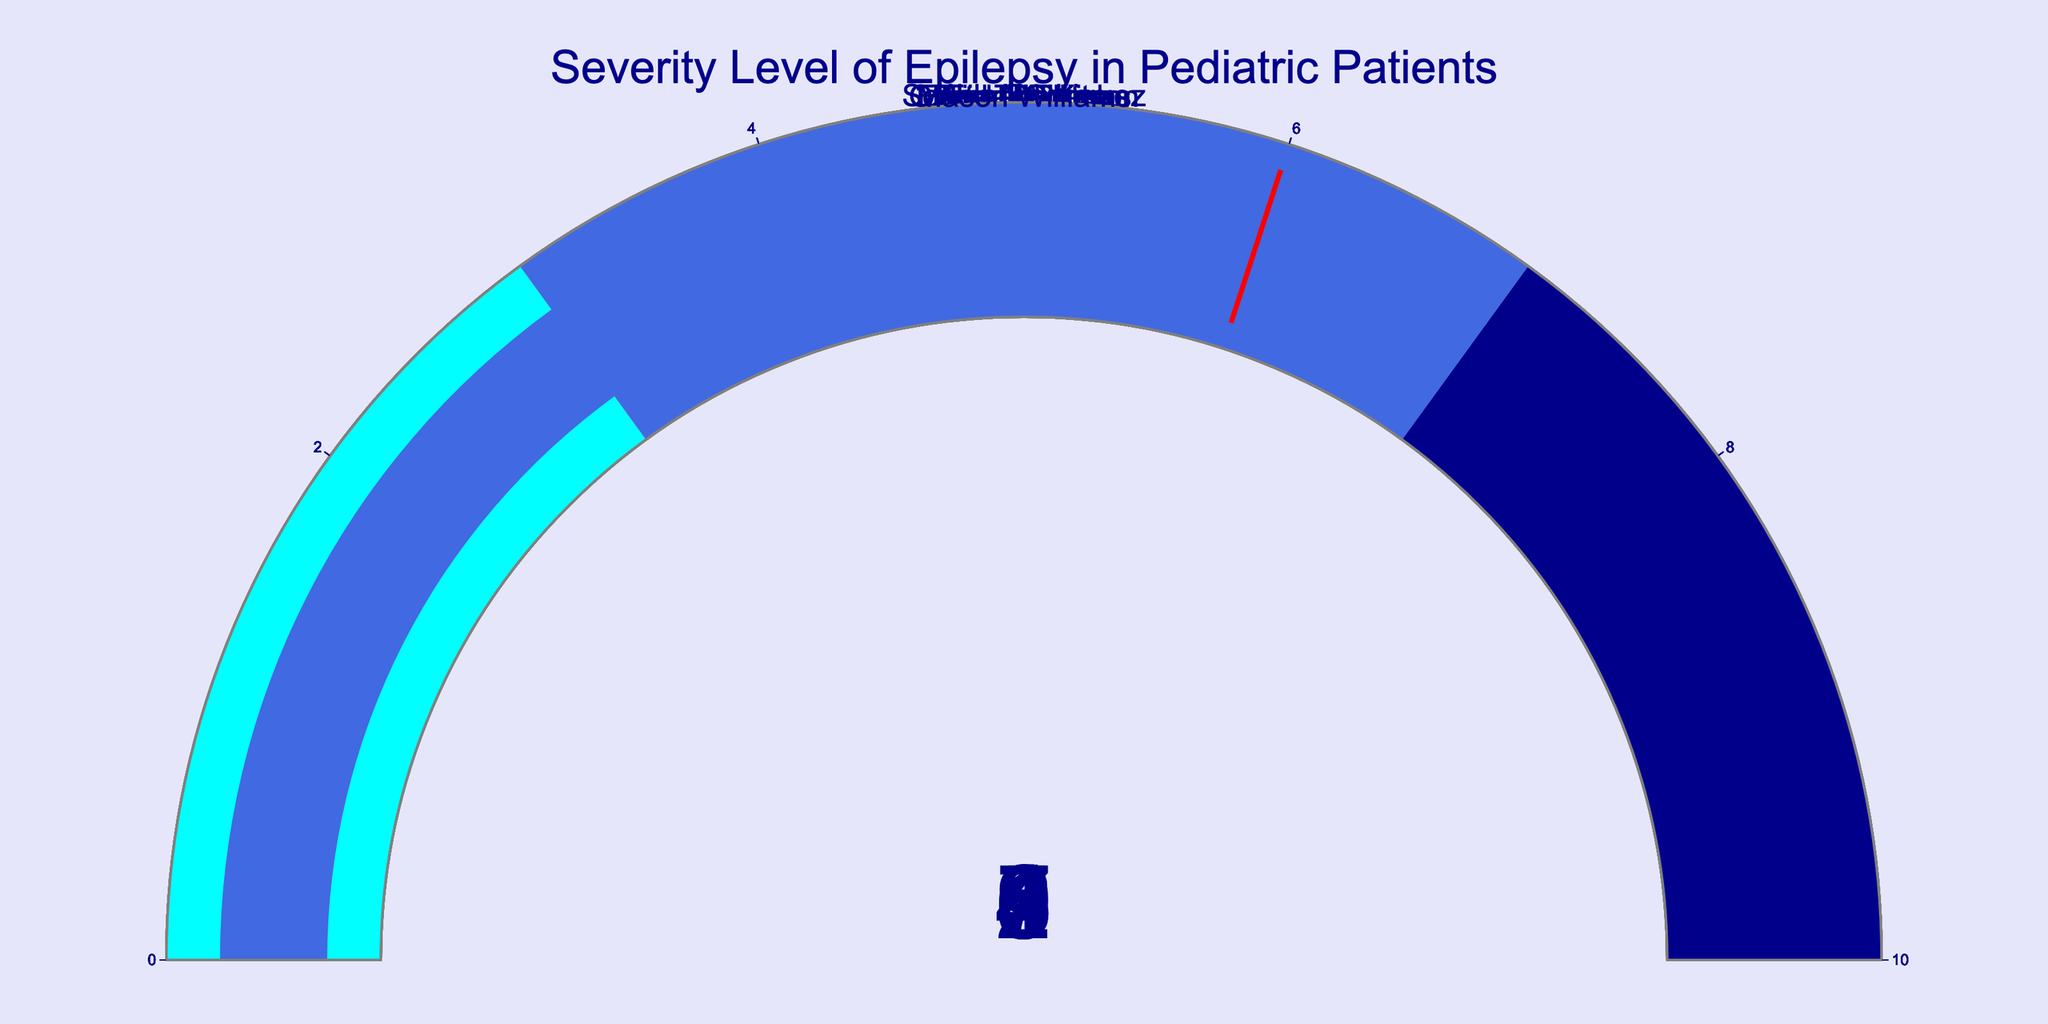What's the range of the severity levels displayed in the figure? The severity levels range from 1 to 10 as indicated on the gauges. The lowest severity level is 1, and the highest is 9.
Answer: 1 to 9 How many patients have a severity level above 5? Looking at the gauges, the patients with a severity level above 5 are Liam Chen (7), Ethan Patel (8), Noah Gupta (6), and Jackson Lee (9), totaling four patients.
Answer: 4 Who has the lowest severity level among the patients? The gauge for Isabella Kim shows a severity level of 1, which is the lowest among all patients.
Answer: Isabella Kim What is the median severity level of the patients? To find the median, first list the severity levels in ascending order: 1, 2, 3, 4, 5, 6, 6, 7, 8, 9. Since there are 10 values, the median will be the average of the 5th and 6th values: (5 + 6) / 2 = 5.5.
Answer: 5.5 Which patient has a severity level close to the average? First, find the average severity level: (1 + 2 + 3 + 4 + 5 + 6 + 6 + 7 + 8 + 9) / 10 = 5.1. The closest severity level to 5.1 is 5, which belongs to Sophia Rodriguez.
Answer: Sophia Rodriguez How many patients fall within the second range of severity levels shown in the figure? The second range on the gauges is from 3 to 7. The patients in this range are Emma Johnson (3), Sophia Rodriguez (5), Ava Nguyen (4), Liam Chen (7), Noah Gupta (6), and Mason Williams (6), totaling six patients.
Answer: 6 Which patient shows a severity level of exactly 9? The gauge for Jackson Lee indicates a severity level of 9.
Answer: Jackson Lee What is the difference in severity levels between Ethan Patel and Emma Johnson? Ethan Patel has a severity level of 8, while Emma Johnson has a severity level of 3. The difference is 8 - 3 = 5.
Answer: 5 Who has a severity level immediately higher than Ava Nguyen? Ava Nguyen has a severity level of 4. The next highest level is 5, which belongs to Sophia Rodriguez.
Answer: Sophia Rodriguez 